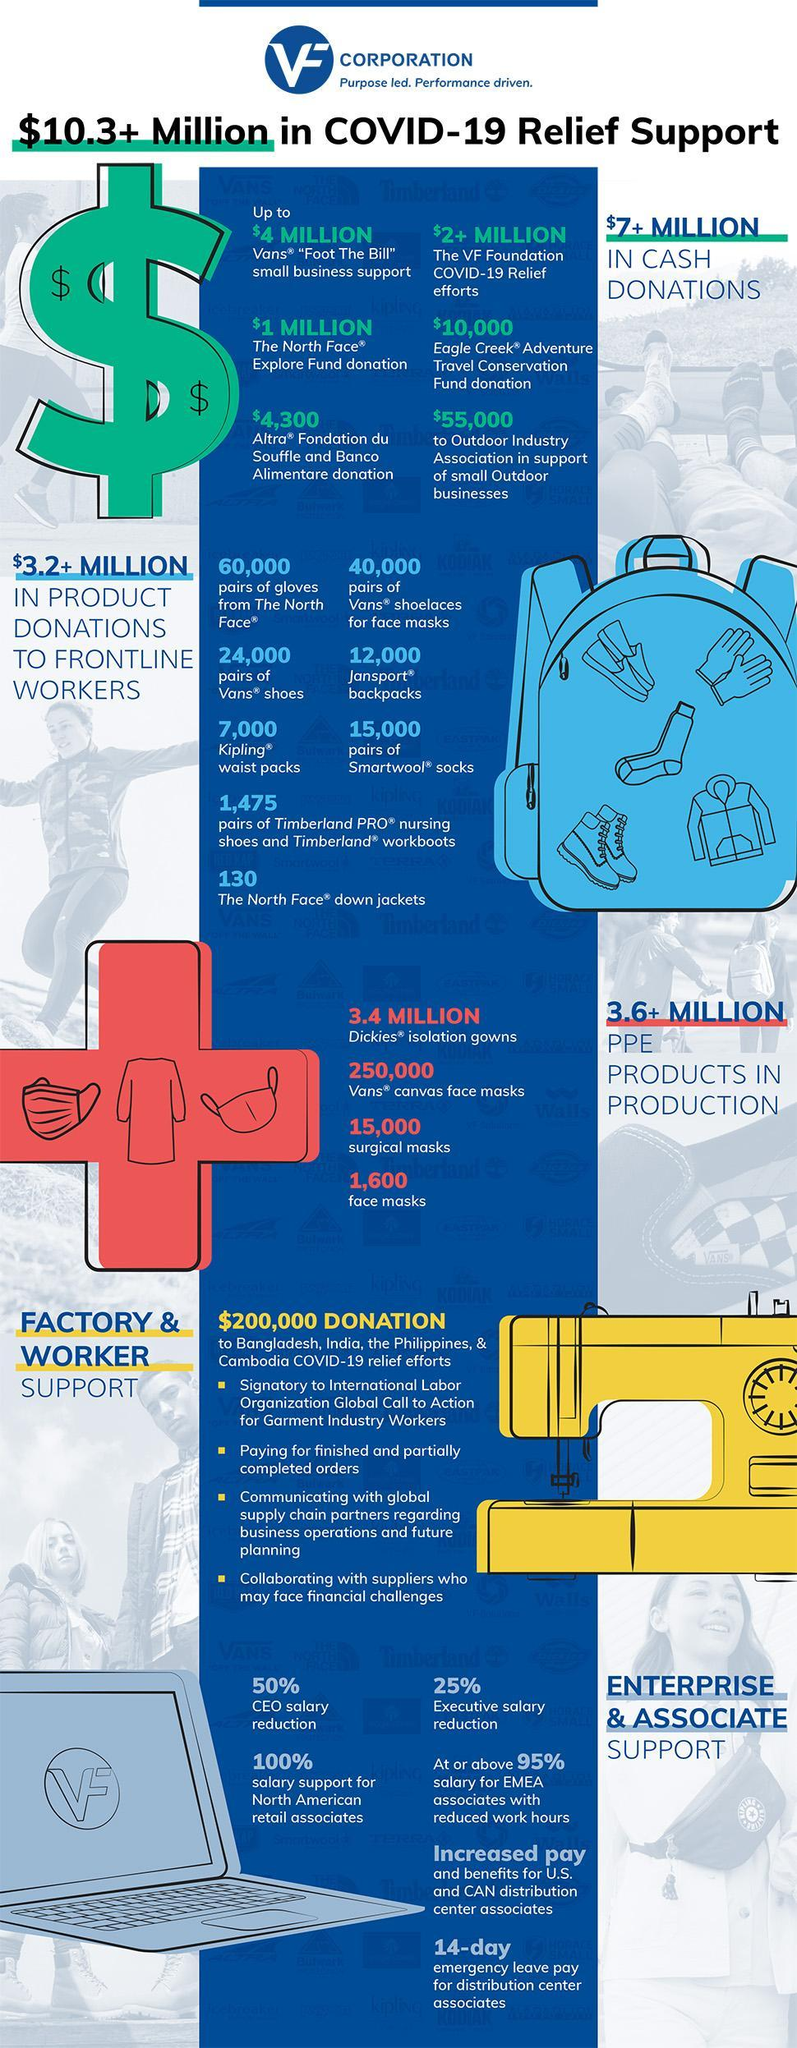Which product has been donated the most?
Answer the question with a short phrase. gloves from The North Face What amount has been donated as cash? $7+ MILLION 